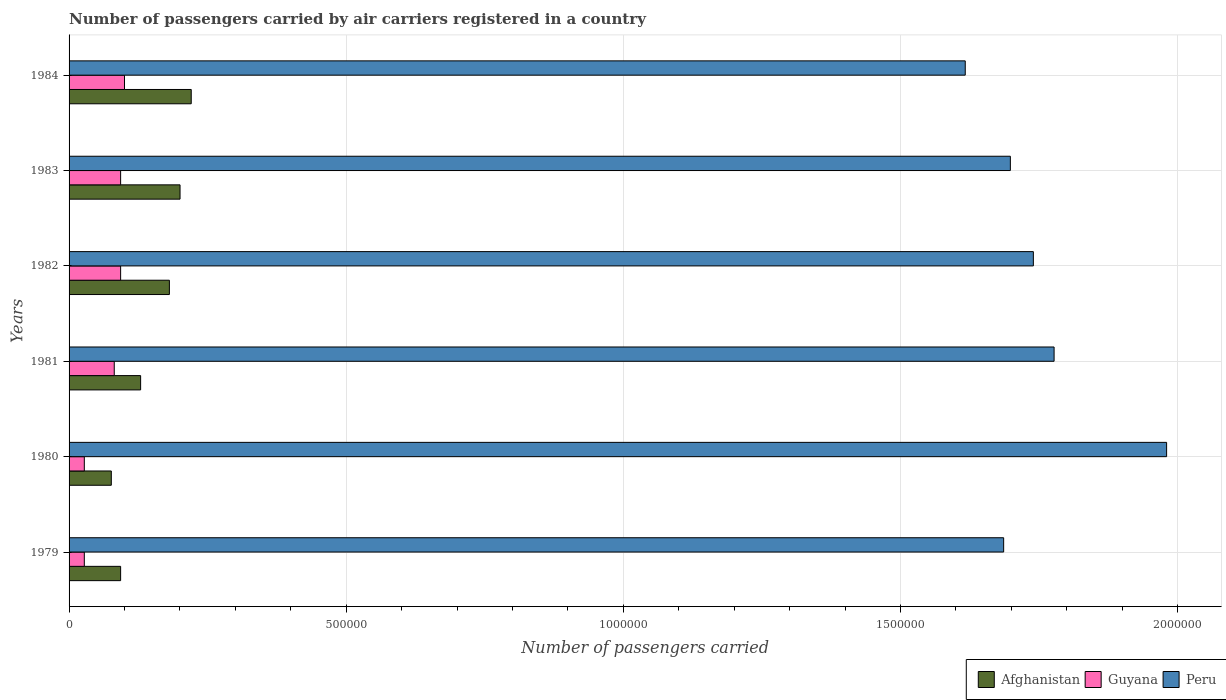How many groups of bars are there?
Provide a succinct answer. 6. Are the number of bars per tick equal to the number of legend labels?
Give a very brief answer. Yes. Are the number of bars on each tick of the Y-axis equal?
Give a very brief answer. Yes. How many bars are there on the 4th tick from the top?
Your answer should be very brief. 3. How many bars are there on the 5th tick from the bottom?
Make the answer very short. 3. What is the label of the 2nd group of bars from the top?
Provide a succinct answer. 1983. In how many cases, is the number of bars for a given year not equal to the number of legend labels?
Give a very brief answer. 0. What is the number of passengers carried by air carriers in Guyana in 1981?
Provide a short and direct response. 8.15e+04. Across all years, what is the maximum number of passengers carried by air carriers in Peru?
Your answer should be very brief. 1.98e+06. Across all years, what is the minimum number of passengers carried by air carriers in Afghanistan?
Offer a very short reply. 7.62e+04. In which year was the number of passengers carried by air carriers in Guyana minimum?
Provide a succinct answer. 1979. What is the total number of passengers carried by air carriers in Guyana in the graph?
Your answer should be very brief. 4.22e+05. What is the difference between the number of passengers carried by air carriers in Afghanistan in 1979 and that in 1981?
Give a very brief answer. -3.61e+04. What is the difference between the number of passengers carried by air carriers in Guyana in 1979 and the number of passengers carried by air carriers in Peru in 1982?
Offer a terse response. -1.71e+06. What is the average number of passengers carried by air carriers in Peru per year?
Your answer should be compact. 1.75e+06. In the year 1979, what is the difference between the number of passengers carried by air carriers in Guyana and number of passengers carried by air carriers in Peru?
Give a very brief answer. -1.66e+06. In how many years, is the number of passengers carried by air carriers in Afghanistan greater than 1000000 ?
Your response must be concise. 0. What is the ratio of the number of passengers carried by air carriers in Guyana in 1980 to that in 1981?
Ensure brevity in your answer.  0.34. Is the difference between the number of passengers carried by air carriers in Guyana in 1979 and 1983 greater than the difference between the number of passengers carried by air carriers in Peru in 1979 and 1983?
Make the answer very short. No. What is the difference between the highest and the second highest number of passengers carried by air carriers in Afghanistan?
Your response must be concise. 2.02e+04. What is the difference between the highest and the lowest number of passengers carried by air carriers in Peru?
Keep it short and to the point. 3.63e+05. In how many years, is the number of passengers carried by air carriers in Guyana greater than the average number of passengers carried by air carriers in Guyana taken over all years?
Make the answer very short. 4. What does the 3rd bar from the top in 1981 represents?
Provide a short and direct response. Afghanistan. What does the 1st bar from the bottom in 1980 represents?
Your answer should be compact. Afghanistan. Is it the case that in every year, the sum of the number of passengers carried by air carriers in Peru and number of passengers carried by air carriers in Afghanistan is greater than the number of passengers carried by air carriers in Guyana?
Keep it short and to the point. Yes. How many bars are there?
Keep it short and to the point. 18. Are all the bars in the graph horizontal?
Keep it short and to the point. Yes. How many years are there in the graph?
Provide a succinct answer. 6. Are the values on the major ticks of X-axis written in scientific E-notation?
Your answer should be very brief. No. How many legend labels are there?
Make the answer very short. 3. What is the title of the graph?
Your response must be concise. Number of passengers carried by air carriers registered in a country. Does "Belarus" appear as one of the legend labels in the graph?
Give a very brief answer. No. What is the label or title of the X-axis?
Offer a very short reply. Number of passengers carried. What is the Number of passengers carried of Afghanistan in 1979?
Your response must be concise. 9.30e+04. What is the Number of passengers carried in Guyana in 1979?
Offer a terse response. 2.75e+04. What is the Number of passengers carried in Peru in 1979?
Give a very brief answer. 1.69e+06. What is the Number of passengers carried of Afghanistan in 1980?
Make the answer very short. 7.62e+04. What is the Number of passengers carried in Guyana in 1980?
Your answer should be very brief. 2.75e+04. What is the Number of passengers carried of Peru in 1980?
Provide a succinct answer. 1.98e+06. What is the Number of passengers carried in Afghanistan in 1981?
Provide a succinct answer. 1.29e+05. What is the Number of passengers carried in Guyana in 1981?
Your response must be concise. 8.15e+04. What is the Number of passengers carried in Peru in 1981?
Offer a terse response. 1.78e+06. What is the Number of passengers carried in Afghanistan in 1982?
Provide a short and direct response. 1.81e+05. What is the Number of passengers carried of Guyana in 1982?
Offer a terse response. 9.30e+04. What is the Number of passengers carried of Peru in 1982?
Keep it short and to the point. 1.74e+06. What is the Number of passengers carried of Afghanistan in 1983?
Your answer should be compact. 2.00e+05. What is the Number of passengers carried of Guyana in 1983?
Provide a succinct answer. 9.30e+04. What is the Number of passengers carried of Peru in 1983?
Your answer should be compact. 1.70e+06. What is the Number of passengers carried of Afghanistan in 1984?
Make the answer very short. 2.20e+05. What is the Number of passengers carried of Guyana in 1984?
Your answer should be compact. 1.00e+05. What is the Number of passengers carried in Peru in 1984?
Make the answer very short. 1.62e+06. Across all years, what is the maximum Number of passengers carried in Afghanistan?
Provide a succinct answer. 2.20e+05. Across all years, what is the maximum Number of passengers carried of Guyana?
Make the answer very short. 1.00e+05. Across all years, what is the maximum Number of passengers carried in Peru?
Ensure brevity in your answer.  1.98e+06. Across all years, what is the minimum Number of passengers carried of Afghanistan?
Provide a succinct answer. 7.62e+04. Across all years, what is the minimum Number of passengers carried of Guyana?
Offer a very short reply. 2.75e+04. Across all years, what is the minimum Number of passengers carried in Peru?
Provide a short and direct response. 1.62e+06. What is the total Number of passengers carried of Afghanistan in the graph?
Provide a succinct answer. 9.00e+05. What is the total Number of passengers carried in Guyana in the graph?
Ensure brevity in your answer.  4.22e+05. What is the total Number of passengers carried in Peru in the graph?
Your answer should be compact. 1.05e+07. What is the difference between the Number of passengers carried of Afghanistan in 1979 and that in 1980?
Your answer should be very brief. 1.68e+04. What is the difference between the Number of passengers carried of Guyana in 1979 and that in 1980?
Keep it short and to the point. 0. What is the difference between the Number of passengers carried of Peru in 1979 and that in 1980?
Give a very brief answer. -2.94e+05. What is the difference between the Number of passengers carried of Afghanistan in 1979 and that in 1981?
Your answer should be compact. -3.61e+04. What is the difference between the Number of passengers carried in Guyana in 1979 and that in 1981?
Offer a terse response. -5.40e+04. What is the difference between the Number of passengers carried in Peru in 1979 and that in 1981?
Ensure brevity in your answer.  -9.10e+04. What is the difference between the Number of passengers carried of Afghanistan in 1979 and that in 1982?
Offer a very short reply. -8.80e+04. What is the difference between the Number of passengers carried in Guyana in 1979 and that in 1982?
Make the answer very short. -6.55e+04. What is the difference between the Number of passengers carried of Peru in 1979 and that in 1982?
Your response must be concise. -5.36e+04. What is the difference between the Number of passengers carried of Afghanistan in 1979 and that in 1983?
Make the answer very short. -1.07e+05. What is the difference between the Number of passengers carried of Guyana in 1979 and that in 1983?
Ensure brevity in your answer.  -6.55e+04. What is the difference between the Number of passengers carried in Peru in 1979 and that in 1983?
Make the answer very short. -1.21e+04. What is the difference between the Number of passengers carried of Afghanistan in 1979 and that in 1984?
Offer a terse response. -1.27e+05. What is the difference between the Number of passengers carried of Guyana in 1979 and that in 1984?
Offer a very short reply. -7.25e+04. What is the difference between the Number of passengers carried of Peru in 1979 and that in 1984?
Provide a succinct answer. 6.93e+04. What is the difference between the Number of passengers carried in Afghanistan in 1980 and that in 1981?
Provide a succinct answer. -5.29e+04. What is the difference between the Number of passengers carried in Guyana in 1980 and that in 1981?
Give a very brief answer. -5.40e+04. What is the difference between the Number of passengers carried in Peru in 1980 and that in 1981?
Make the answer very short. 2.03e+05. What is the difference between the Number of passengers carried of Afghanistan in 1980 and that in 1982?
Keep it short and to the point. -1.05e+05. What is the difference between the Number of passengers carried of Guyana in 1980 and that in 1982?
Keep it short and to the point. -6.55e+04. What is the difference between the Number of passengers carried in Peru in 1980 and that in 1982?
Your response must be concise. 2.40e+05. What is the difference between the Number of passengers carried of Afghanistan in 1980 and that in 1983?
Provide a succinct answer. -1.24e+05. What is the difference between the Number of passengers carried in Guyana in 1980 and that in 1983?
Make the answer very short. -6.55e+04. What is the difference between the Number of passengers carried in Peru in 1980 and that in 1983?
Offer a very short reply. 2.82e+05. What is the difference between the Number of passengers carried in Afghanistan in 1980 and that in 1984?
Ensure brevity in your answer.  -1.44e+05. What is the difference between the Number of passengers carried of Guyana in 1980 and that in 1984?
Provide a succinct answer. -7.25e+04. What is the difference between the Number of passengers carried in Peru in 1980 and that in 1984?
Provide a short and direct response. 3.63e+05. What is the difference between the Number of passengers carried of Afghanistan in 1981 and that in 1982?
Your response must be concise. -5.19e+04. What is the difference between the Number of passengers carried in Guyana in 1981 and that in 1982?
Your answer should be very brief. -1.15e+04. What is the difference between the Number of passengers carried in Peru in 1981 and that in 1982?
Offer a very short reply. 3.74e+04. What is the difference between the Number of passengers carried in Afghanistan in 1981 and that in 1983?
Ensure brevity in your answer.  -7.11e+04. What is the difference between the Number of passengers carried of Guyana in 1981 and that in 1983?
Provide a short and direct response. -1.15e+04. What is the difference between the Number of passengers carried of Peru in 1981 and that in 1983?
Make the answer very short. 7.89e+04. What is the difference between the Number of passengers carried of Afghanistan in 1981 and that in 1984?
Provide a succinct answer. -9.13e+04. What is the difference between the Number of passengers carried in Guyana in 1981 and that in 1984?
Give a very brief answer. -1.85e+04. What is the difference between the Number of passengers carried of Peru in 1981 and that in 1984?
Your answer should be compact. 1.60e+05. What is the difference between the Number of passengers carried of Afghanistan in 1982 and that in 1983?
Offer a very short reply. -1.92e+04. What is the difference between the Number of passengers carried in Peru in 1982 and that in 1983?
Offer a very short reply. 4.15e+04. What is the difference between the Number of passengers carried in Afghanistan in 1982 and that in 1984?
Your answer should be very brief. -3.94e+04. What is the difference between the Number of passengers carried of Guyana in 1982 and that in 1984?
Provide a succinct answer. -7000. What is the difference between the Number of passengers carried in Peru in 1982 and that in 1984?
Provide a succinct answer. 1.23e+05. What is the difference between the Number of passengers carried of Afghanistan in 1983 and that in 1984?
Provide a short and direct response. -2.02e+04. What is the difference between the Number of passengers carried of Guyana in 1983 and that in 1984?
Make the answer very short. -7000. What is the difference between the Number of passengers carried in Peru in 1983 and that in 1984?
Your response must be concise. 8.14e+04. What is the difference between the Number of passengers carried in Afghanistan in 1979 and the Number of passengers carried in Guyana in 1980?
Offer a terse response. 6.55e+04. What is the difference between the Number of passengers carried of Afghanistan in 1979 and the Number of passengers carried of Peru in 1980?
Provide a short and direct response. -1.89e+06. What is the difference between the Number of passengers carried of Guyana in 1979 and the Number of passengers carried of Peru in 1980?
Keep it short and to the point. -1.95e+06. What is the difference between the Number of passengers carried of Afghanistan in 1979 and the Number of passengers carried of Guyana in 1981?
Keep it short and to the point. 1.15e+04. What is the difference between the Number of passengers carried of Afghanistan in 1979 and the Number of passengers carried of Peru in 1981?
Provide a short and direct response. -1.68e+06. What is the difference between the Number of passengers carried in Guyana in 1979 and the Number of passengers carried in Peru in 1981?
Provide a succinct answer. -1.75e+06. What is the difference between the Number of passengers carried in Afghanistan in 1979 and the Number of passengers carried in Peru in 1982?
Give a very brief answer. -1.65e+06. What is the difference between the Number of passengers carried of Guyana in 1979 and the Number of passengers carried of Peru in 1982?
Your answer should be very brief. -1.71e+06. What is the difference between the Number of passengers carried in Afghanistan in 1979 and the Number of passengers carried in Guyana in 1983?
Your answer should be compact. 0. What is the difference between the Number of passengers carried in Afghanistan in 1979 and the Number of passengers carried in Peru in 1983?
Your response must be concise. -1.61e+06. What is the difference between the Number of passengers carried in Guyana in 1979 and the Number of passengers carried in Peru in 1983?
Your response must be concise. -1.67e+06. What is the difference between the Number of passengers carried in Afghanistan in 1979 and the Number of passengers carried in Guyana in 1984?
Keep it short and to the point. -7000. What is the difference between the Number of passengers carried of Afghanistan in 1979 and the Number of passengers carried of Peru in 1984?
Give a very brief answer. -1.52e+06. What is the difference between the Number of passengers carried in Guyana in 1979 and the Number of passengers carried in Peru in 1984?
Make the answer very short. -1.59e+06. What is the difference between the Number of passengers carried of Afghanistan in 1980 and the Number of passengers carried of Guyana in 1981?
Offer a terse response. -5300. What is the difference between the Number of passengers carried of Afghanistan in 1980 and the Number of passengers carried of Peru in 1981?
Your answer should be compact. -1.70e+06. What is the difference between the Number of passengers carried of Guyana in 1980 and the Number of passengers carried of Peru in 1981?
Your answer should be compact. -1.75e+06. What is the difference between the Number of passengers carried of Afghanistan in 1980 and the Number of passengers carried of Guyana in 1982?
Give a very brief answer. -1.68e+04. What is the difference between the Number of passengers carried in Afghanistan in 1980 and the Number of passengers carried in Peru in 1982?
Provide a succinct answer. -1.66e+06. What is the difference between the Number of passengers carried in Guyana in 1980 and the Number of passengers carried in Peru in 1982?
Make the answer very short. -1.71e+06. What is the difference between the Number of passengers carried in Afghanistan in 1980 and the Number of passengers carried in Guyana in 1983?
Your answer should be compact. -1.68e+04. What is the difference between the Number of passengers carried in Afghanistan in 1980 and the Number of passengers carried in Peru in 1983?
Your answer should be very brief. -1.62e+06. What is the difference between the Number of passengers carried in Guyana in 1980 and the Number of passengers carried in Peru in 1983?
Keep it short and to the point. -1.67e+06. What is the difference between the Number of passengers carried of Afghanistan in 1980 and the Number of passengers carried of Guyana in 1984?
Offer a very short reply. -2.38e+04. What is the difference between the Number of passengers carried in Afghanistan in 1980 and the Number of passengers carried in Peru in 1984?
Keep it short and to the point. -1.54e+06. What is the difference between the Number of passengers carried in Guyana in 1980 and the Number of passengers carried in Peru in 1984?
Make the answer very short. -1.59e+06. What is the difference between the Number of passengers carried in Afghanistan in 1981 and the Number of passengers carried in Guyana in 1982?
Provide a short and direct response. 3.61e+04. What is the difference between the Number of passengers carried in Afghanistan in 1981 and the Number of passengers carried in Peru in 1982?
Your answer should be very brief. -1.61e+06. What is the difference between the Number of passengers carried in Guyana in 1981 and the Number of passengers carried in Peru in 1982?
Keep it short and to the point. -1.66e+06. What is the difference between the Number of passengers carried in Afghanistan in 1981 and the Number of passengers carried in Guyana in 1983?
Your answer should be compact. 3.61e+04. What is the difference between the Number of passengers carried of Afghanistan in 1981 and the Number of passengers carried of Peru in 1983?
Your answer should be compact. -1.57e+06. What is the difference between the Number of passengers carried in Guyana in 1981 and the Number of passengers carried in Peru in 1983?
Give a very brief answer. -1.62e+06. What is the difference between the Number of passengers carried in Afghanistan in 1981 and the Number of passengers carried in Guyana in 1984?
Provide a short and direct response. 2.91e+04. What is the difference between the Number of passengers carried of Afghanistan in 1981 and the Number of passengers carried of Peru in 1984?
Provide a short and direct response. -1.49e+06. What is the difference between the Number of passengers carried in Guyana in 1981 and the Number of passengers carried in Peru in 1984?
Your answer should be very brief. -1.54e+06. What is the difference between the Number of passengers carried in Afghanistan in 1982 and the Number of passengers carried in Guyana in 1983?
Ensure brevity in your answer.  8.80e+04. What is the difference between the Number of passengers carried of Afghanistan in 1982 and the Number of passengers carried of Peru in 1983?
Offer a very short reply. -1.52e+06. What is the difference between the Number of passengers carried in Guyana in 1982 and the Number of passengers carried in Peru in 1983?
Provide a short and direct response. -1.61e+06. What is the difference between the Number of passengers carried of Afghanistan in 1982 and the Number of passengers carried of Guyana in 1984?
Give a very brief answer. 8.10e+04. What is the difference between the Number of passengers carried in Afghanistan in 1982 and the Number of passengers carried in Peru in 1984?
Offer a very short reply. -1.44e+06. What is the difference between the Number of passengers carried in Guyana in 1982 and the Number of passengers carried in Peru in 1984?
Your response must be concise. -1.52e+06. What is the difference between the Number of passengers carried in Afghanistan in 1983 and the Number of passengers carried in Guyana in 1984?
Your response must be concise. 1.00e+05. What is the difference between the Number of passengers carried of Afghanistan in 1983 and the Number of passengers carried of Peru in 1984?
Keep it short and to the point. -1.42e+06. What is the difference between the Number of passengers carried in Guyana in 1983 and the Number of passengers carried in Peru in 1984?
Offer a terse response. -1.52e+06. What is the average Number of passengers carried in Afghanistan per year?
Provide a succinct answer. 1.50e+05. What is the average Number of passengers carried in Guyana per year?
Ensure brevity in your answer.  7.04e+04. What is the average Number of passengers carried in Peru per year?
Provide a succinct answer. 1.75e+06. In the year 1979, what is the difference between the Number of passengers carried in Afghanistan and Number of passengers carried in Guyana?
Offer a terse response. 6.55e+04. In the year 1979, what is the difference between the Number of passengers carried of Afghanistan and Number of passengers carried of Peru?
Offer a very short reply. -1.59e+06. In the year 1979, what is the difference between the Number of passengers carried of Guyana and Number of passengers carried of Peru?
Your answer should be compact. -1.66e+06. In the year 1980, what is the difference between the Number of passengers carried of Afghanistan and Number of passengers carried of Guyana?
Your answer should be compact. 4.87e+04. In the year 1980, what is the difference between the Number of passengers carried in Afghanistan and Number of passengers carried in Peru?
Provide a short and direct response. -1.90e+06. In the year 1980, what is the difference between the Number of passengers carried in Guyana and Number of passengers carried in Peru?
Make the answer very short. -1.95e+06. In the year 1981, what is the difference between the Number of passengers carried of Afghanistan and Number of passengers carried of Guyana?
Offer a terse response. 4.76e+04. In the year 1981, what is the difference between the Number of passengers carried of Afghanistan and Number of passengers carried of Peru?
Your answer should be very brief. -1.65e+06. In the year 1981, what is the difference between the Number of passengers carried in Guyana and Number of passengers carried in Peru?
Ensure brevity in your answer.  -1.70e+06. In the year 1982, what is the difference between the Number of passengers carried of Afghanistan and Number of passengers carried of Guyana?
Your response must be concise. 8.80e+04. In the year 1982, what is the difference between the Number of passengers carried in Afghanistan and Number of passengers carried in Peru?
Keep it short and to the point. -1.56e+06. In the year 1982, what is the difference between the Number of passengers carried of Guyana and Number of passengers carried of Peru?
Provide a succinct answer. -1.65e+06. In the year 1983, what is the difference between the Number of passengers carried in Afghanistan and Number of passengers carried in Guyana?
Provide a succinct answer. 1.07e+05. In the year 1983, what is the difference between the Number of passengers carried of Afghanistan and Number of passengers carried of Peru?
Your answer should be very brief. -1.50e+06. In the year 1983, what is the difference between the Number of passengers carried of Guyana and Number of passengers carried of Peru?
Offer a very short reply. -1.61e+06. In the year 1984, what is the difference between the Number of passengers carried of Afghanistan and Number of passengers carried of Guyana?
Offer a very short reply. 1.20e+05. In the year 1984, what is the difference between the Number of passengers carried in Afghanistan and Number of passengers carried in Peru?
Give a very brief answer. -1.40e+06. In the year 1984, what is the difference between the Number of passengers carried of Guyana and Number of passengers carried of Peru?
Your answer should be compact. -1.52e+06. What is the ratio of the Number of passengers carried of Afghanistan in 1979 to that in 1980?
Make the answer very short. 1.22. What is the ratio of the Number of passengers carried of Guyana in 1979 to that in 1980?
Provide a succinct answer. 1. What is the ratio of the Number of passengers carried of Peru in 1979 to that in 1980?
Your answer should be compact. 0.85. What is the ratio of the Number of passengers carried in Afghanistan in 1979 to that in 1981?
Offer a very short reply. 0.72. What is the ratio of the Number of passengers carried of Guyana in 1979 to that in 1981?
Give a very brief answer. 0.34. What is the ratio of the Number of passengers carried in Peru in 1979 to that in 1981?
Make the answer very short. 0.95. What is the ratio of the Number of passengers carried of Afghanistan in 1979 to that in 1982?
Keep it short and to the point. 0.51. What is the ratio of the Number of passengers carried in Guyana in 1979 to that in 1982?
Offer a terse response. 0.3. What is the ratio of the Number of passengers carried in Peru in 1979 to that in 1982?
Provide a short and direct response. 0.97. What is the ratio of the Number of passengers carried in Afghanistan in 1979 to that in 1983?
Provide a short and direct response. 0.46. What is the ratio of the Number of passengers carried of Guyana in 1979 to that in 1983?
Provide a succinct answer. 0.3. What is the ratio of the Number of passengers carried in Afghanistan in 1979 to that in 1984?
Give a very brief answer. 0.42. What is the ratio of the Number of passengers carried of Guyana in 1979 to that in 1984?
Keep it short and to the point. 0.28. What is the ratio of the Number of passengers carried of Peru in 1979 to that in 1984?
Your response must be concise. 1.04. What is the ratio of the Number of passengers carried in Afghanistan in 1980 to that in 1981?
Provide a succinct answer. 0.59. What is the ratio of the Number of passengers carried in Guyana in 1980 to that in 1981?
Your response must be concise. 0.34. What is the ratio of the Number of passengers carried in Peru in 1980 to that in 1981?
Your response must be concise. 1.11. What is the ratio of the Number of passengers carried in Afghanistan in 1980 to that in 1982?
Offer a very short reply. 0.42. What is the ratio of the Number of passengers carried in Guyana in 1980 to that in 1982?
Make the answer very short. 0.3. What is the ratio of the Number of passengers carried in Peru in 1980 to that in 1982?
Keep it short and to the point. 1.14. What is the ratio of the Number of passengers carried in Afghanistan in 1980 to that in 1983?
Offer a terse response. 0.38. What is the ratio of the Number of passengers carried of Guyana in 1980 to that in 1983?
Ensure brevity in your answer.  0.3. What is the ratio of the Number of passengers carried of Peru in 1980 to that in 1983?
Ensure brevity in your answer.  1.17. What is the ratio of the Number of passengers carried in Afghanistan in 1980 to that in 1984?
Your answer should be very brief. 0.35. What is the ratio of the Number of passengers carried in Guyana in 1980 to that in 1984?
Your response must be concise. 0.28. What is the ratio of the Number of passengers carried in Peru in 1980 to that in 1984?
Offer a very short reply. 1.22. What is the ratio of the Number of passengers carried in Afghanistan in 1981 to that in 1982?
Your response must be concise. 0.71. What is the ratio of the Number of passengers carried of Guyana in 1981 to that in 1982?
Your answer should be compact. 0.88. What is the ratio of the Number of passengers carried in Peru in 1981 to that in 1982?
Your response must be concise. 1.02. What is the ratio of the Number of passengers carried of Afghanistan in 1981 to that in 1983?
Your response must be concise. 0.64. What is the ratio of the Number of passengers carried of Guyana in 1981 to that in 1983?
Your response must be concise. 0.88. What is the ratio of the Number of passengers carried of Peru in 1981 to that in 1983?
Provide a succinct answer. 1.05. What is the ratio of the Number of passengers carried of Afghanistan in 1981 to that in 1984?
Ensure brevity in your answer.  0.59. What is the ratio of the Number of passengers carried in Guyana in 1981 to that in 1984?
Provide a succinct answer. 0.81. What is the ratio of the Number of passengers carried of Peru in 1981 to that in 1984?
Your answer should be compact. 1.1. What is the ratio of the Number of passengers carried of Afghanistan in 1982 to that in 1983?
Offer a very short reply. 0.9. What is the ratio of the Number of passengers carried in Guyana in 1982 to that in 1983?
Give a very brief answer. 1. What is the ratio of the Number of passengers carried in Peru in 1982 to that in 1983?
Keep it short and to the point. 1.02. What is the ratio of the Number of passengers carried of Afghanistan in 1982 to that in 1984?
Your response must be concise. 0.82. What is the ratio of the Number of passengers carried in Peru in 1982 to that in 1984?
Keep it short and to the point. 1.08. What is the ratio of the Number of passengers carried in Afghanistan in 1983 to that in 1984?
Ensure brevity in your answer.  0.91. What is the ratio of the Number of passengers carried in Guyana in 1983 to that in 1984?
Provide a short and direct response. 0.93. What is the ratio of the Number of passengers carried of Peru in 1983 to that in 1984?
Ensure brevity in your answer.  1.05. What is the difference between the highest and the second highest Number of passengers carried in Afghanistan?
Keep it short and to the point. 2.02e+04. What is the difference between the highest and the second highest Number of passengers carried in Guyana?
Provide a short and direct response. 7000. What is the difference between the highest and the second highest Number of passengers carried of Peru?
Provide a short and direct response. 2.03e+05. What is the difference between the highest and the lowest Number of passengers carried of Afghanistan?
Make the answer very short. 1.44e+05. What is the difference between the highest and the lowest Number of passengers carried of Guyana?
Provide a short and direct response. 7.25e+04. What is the difference between the highest and the lowest Number of passengers carried of Peru?
Keep it short and to the point. 3.63e+05. 